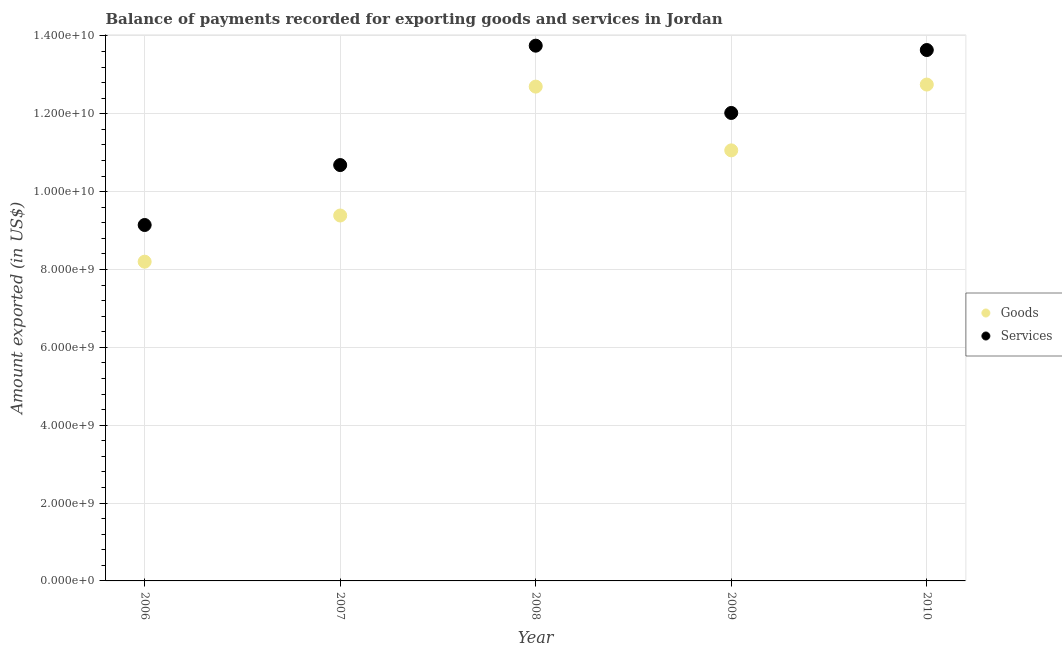How many different coloured dotlines are there?
Your answer should be compact. 2. Is the number of dotlines equal to the number of legend labels?
Offer a terse response. Yes. What is the amount of services exported in 2006?
Give a very brief answer. 9.14e+09. Across all years, what is the maximum amount of services exported?
Your answer should be compact. 1.38e+1. Across all years, what is the minimum amount of goods exported?
Your answer should be very brief. 8.20e+09. In which year was the amount of goods exported maximum?
Ensure brevity in your answer.  2010. In which year was the amount of goods exported minimum?
Your answer should be very brief. 2006. What is the total amount of goods exported in the graph?
Give a very brief answer. 5.41e+1. What is the difference between the amount of services exported in 2007 and that in 2008?
Your response must be concise. -3.07e+09. What is the difference between the amount of goods exported in 2007 and the amount of services exported in 2006?
Keep it short and to the point. 2.44e+08. What is the average amount of goods exported per year?
Your answer should be compact. 1.08e+1. In the year 2010, what is the difference between the amount of services exported and amount of goods exported?
Give a very brief answer. 8.87e+08. In how many years, is the amount of goods exported greater than 800000000 US$?
Your answer should be compact. 5. What is the ratio of the amount of goods exported in 2007 to that in 2009?
Ensure brevity in your answer.  0.85. Is the difference between the amount of services exported in 2008 and 2010 greater than the difference between the amount of goods exported in 2008 and 2010?
Give a very brief answer. Yes. What is the difference between the highest and the second highest amount of services exported?
Ensure brevity in your answer.  1.12e+08. What is the difference between the highest and the lowest amount of services exported?
Offer a terse response. 4.61e+09. In how many years, is the amount of services exported greater than the average amount of services exported taken over all years?
Make the answer very short. 3. Is the sum of the amount of services exported in 2006 and 2008 greater than the maximum amount of goods exported across all years?
Ensure brevity in your answer.  Yes. Does the amount of goods exported monotonically increase over the years?
Ensure brevity in your answer.  No. Is the amount of goods exported strictly greater than the amount of services exported over the years?
Your response must be concise. No. How many years are there in the graph?
Your answer should be very brief. 5. Are the values on the major ticks of Y-axis written in scientific E-notation?
Your answer should be very brief. Yes. Does the graph contain grids?
Make the answer very short. Yes. Where does the legend appear in the graph?
Your response must be concise. Center right. How are the legend labels stacked?
Keep it short and to the point. Vertical. What is the title of the graph?
Offer a terse response. Balance of payments recorded for exporting goods and services in Jordan. What is the label or title of the X-axis?
Give a very brief answer. Year. What is the label or title of the Y-axis?
Offer a very short reply. Amount exported (in US$). What is the Amount exported (in US$) in Goods in 2006?
Provide a succinct answer. 8.20e+09. What is the Amount exported (in US$) in Services in 2006?
Keep it short and to the point. 9.14e+09. What is the Amount exported (in US$) of Goods in 2007?
Give a very brief answer. 9.39e+09. What is the Amount exported (in US$) of Services in 2007?
Give a very brief answer. 1.07e+1. What is the Amount exported (in US$) of Goods in 2008?
Offer a terse response. 1.27e+1. What is the Amount exported (in US$) in Services in 2008?
Keep it short and to the point. 1.38e+1. What is the Amount exported (in US$) of Goods in 2009?
Your answer should be compact. 1.11e+1. What is the Amount exported (in US$) of Services in 2009?
Your response must be concise. 1.20e+1. What is the Amount exported (in US$) in Goods in 2010?
Your answer should be very brief. 1.28e+1. What is the Amount exported (in US$) in Services in 2010?
Keep it short and to the point. 1.36e+1. Across all years, what is the maximum Amount exported (in US$) of Goods?
Keep it short and to the point. 1.28e+1. Across all years, what is the maximum Amount exported (in US$) of Services?
Make the answer very short. 1.38e+1. Across all years, what is the minimum Amount exported (in US$) in Goods?
Offer a very short reply. 8.20e+09. Across all years, what is the minimum Amount exported (in US$) in Services?
Ensure brevity in your answer.  9.14e+09. What is the total Amount exported (in US$) of Goods in the graph?
Keep it short and to the point. 5.41e+1. What is the total Amount exported (in US$) of Services in the graph?
Offer a terse response. 5.92e+1. What is the difference between the Amount exported (in US$) of Goods in 2006 and that in 2007?
Keep it short and to the point. -1.19e+09. What is the difference between the Amount exported (in US$) in Services in 2006 and that in 2007?
Offer a very short reply. -1.54e+09. What is the difference between the Amount exported (in US$) of Goods in 2006 and that in 2008?
Your answer should be very brief. -4.50e+09. What is the difference between the Amount exported (in US$) in Services in 2006 and that in 2008?
Offer a terse response. -4.61e+09. What is the difference between the Amount exported (in US$) of Goods in 2006 and that in 2009?
Provide a short and direct response. -2.86e+09. What is the difference between the Amount exported (in US$) of Services in 2006 and that in 2009?
Provide a short and direct response. -2.88e+09. What is the difference between the Amount exported (in US$) in Goods in 2006 and that in 2010?
Provide a short and direct response. -4.55e+09. What is the difference between the Amount exported (in US$) of Services in 2006 and that in 2010?
Your response must be concise. -4.50e+09. What is the difference between the Amount exported (in US$) in Goods in 2007 and that in 2008?
Your response must be concise. -3.31e+09. What is the difference between the Amount exported (in US$) of Services in 2007 and that in 2008?
Make the answer very short. -3.07e+09. What is the difference between the Amount exported (in US$) of Goods in 2007 and that in 2009?
Provide a short and direct response. -1.67e+09. What is the difference between the Amount exported (in US$) of Services in 2007 and that in 2009?
Give a very brief answer. -1.34e+09. What is the difference between the Amount exported (in US$) of Goods in 2007 and that in 2010?
Your response must be concise. -3.36e+09. What is the difference between the Amount exported (in US$) of Services in 2007 and that in 2010?
Ensure brevity in your answer.  -2.96e+09. What is the difference between the Amount exported (in US$) of Goods in 2008 and that in 2009?
Give a very brief answer. 1.64e+09. What is the difference between the Amount exported (in US$) of Services in 2008 and that in 2009?
Make the answer very short. 1.73e+09. What is the difference between the Amount exported (in US$) of Goods in 2008 and that in 2010?
Your answer should be compact. -5.28e+07. What is the difference between the Amount exported (in US$) in Services in 2008 and that in 2010?
Offer a very short reply. 1.12e+08. What is the difference between the Amount exported (in US$) in Goods in 2009 and that in 2010?
Offer a terse response. -1.69e+09. What is the difference between the Amount exported (in US$) in Services in 2009 and that in 2010?
Provide a succinct answer. -1.62e+09. What is the difference between the Amount exported (in US$) of Goods in 2006 and the Amount exported (in US$) of Services in 2007?
Your response must be concise. -2.48e+09. What is the difference between the Amount exported (in US$) of Goods in 2006 and the Amount exported (in US$) of Services in 2008?
Offer a terse response. -5.55e+09. What is the difference between the Amount exported (in US$) of Goods in 2006 and the Amount exported (in US$) of Services in 2009?
Your answer should be compact. -3.82e+09. What is the difference between the Amount exported (in US$) in Goods in 2006 and the Amount exported (in US$) in Services in 2010?
Give a very brief answer. -5.44e+09. What is the difference between the Amount exported (in US$) in Goods in 2007 and the Amount exported (in US$) in Services in 2008?
Ensure brevity in your answer.  -4.36e+09. What is the difference between the Amount exported (in US$) in Goods in 2007 and the Amount exported (in US$) in Services in 2009?
Your answer should be very brief. -2.63e+09. What is the difference between the Amount exported (in US$) in Goods in 2007 and the Amount exported (in US$) in Services in 2010?
Your response must be concise. -4.25e+09. What is the difference between the Amount exported (in US$) in Goods in 2008 and the Amount exported (in US$) in Services in 2009?
Provide a succinct answer. 6.77e+08. What is the difference between the Amount exported (in US$) in Goods in 2008 and the Amount exported (in US$) in Services in 2010?
Your response must be concise. -9.40e+08. What is the difference between the Amount exported (in US$) in Goods in 2009 and the Amount exported (in US$) in Services in 2010?
Provide a short and direct response. -2.58e+09. What is the average Amount exported (in US$) in Goods per year?
Your answer should be very brief. 1.08e+1. What is the average Amount exported (in US$) of Services per year?
Ensure brevity in your answer.  1.18e+1. In the year 2006, what is the difference between the Amount exported (in US$) of Goods and Amount exported (in US$) of Services?
Offer a terse response. -9.43e+08. In the year 2007, what is the difference between the Amount exported (in US$) in Goods and Amount exported (in US$) in Services?
Keep it short and to the point. -1.30e+09. In the year 2008, what is the difference between the Amount exported (in US$) in Goods and Amount exported (in US$) in Services?
Your answer should be compact. -1.05e+09. In the year 2009, what is the difference between the Amount exported (in US$) in Goods and Amount exported (in US$) in Services?
Your response must be concise. -9.61e+08. In the year 2010, what is the difference between the Amount exported (in US$) of Goods and Amount exported (in US$) of Services?
Give a very brief answer. -8.87e+08. What is the ratio of the Amount exported (in US$) in Goods in 2006 to that in 2007?
Give a very brief answer. 0.87. What is the ratio of the Amount exported (in US$) of Services in 2006 to that in 2007?
Keep it short and to the point. 0.86. What is the ratio of the Amount exported (in US$) in Goods in 2006 to that in 2008?
Offer a very short reply. 0.65. What is the ratio of the Amount exported (in US$) in Services in 2006 to that in 2008?
Your response must be concise. 0.67. What is the ratio of the Amount exported (in US$) in Goods in 2006 to that in 2009?
Provide a succinct answer. 0.74. What is the ratio of the Amount exported (in US$) of Services in 2006 to that in 2009?
Your answer should be very brief. 0.76. What is the ratio of the Amount exported (in US$) of Goods in 2006 to that in 2010?
Provide a short and direct response. 0.64. What is the ratio of the Amount exported (in US$) of Services in 2006 to that in 2010?
Provide a succinct answer. 0.67. What is the ratio of the Amount exported (in US$) in Goods in 2007 to that in 2008?
Ensure brevity in your answer.  0.74. What is the ratio of the Amount exported (in US$) of Services in 2007 to that in 2008?
Provide a short and direct response. 0.78. What is the ratio of the Amount exported (in US$) in Goods in 2007 to that in 2009?
Provide a short and direct response. 0.85. What is the ratio of the Amount exported (in US$) of Services in 2007 to that in 2009?
Make the answer very short. 0.89. What is the ratio of the Amount exported (in US$) in Goods in 2007 to that in 2010?
Give a very brief answer. 0.74. What is the ratio of the Amount exported (in US$) in Services in 2007 to that in 2010?
Provide a succinct answer. 0.78. What is the ratio of the Amount exported (in US$) in Goods in 2008 to that in 2009?
Your answer should be very brief. 1.15. What is the ratio of the Amount exported (in US$) of Services in 2008 to that in 2009?
Your answer should be compact. 1.14. What is the ratio of the Amount exported (in US$) of Goods in 2008 to that in 2010?
Provide a succinct answer. 1. What is the ratio of the Amount exported (in US$) in Services in 2008 to that in 2010?
Give a very brief answer. 1.01. What is the ratio of the Amount exported (in US$) of Goods in 2009 to that in 2010?
Offer a terse response. 0.87. What is the ratio of the Amount exported (in US$) in Services in 2009 to that in 2010?
Your answer should be very brief. 0.88. What is the difference between the highest and the second highest Amount exported (in US$) of Goods?
Provide a succinct answer. 5.28e+07. What is the difference between the highest and the second highest Amount exported (in US$) of Services?
Offer a very short reply. 1.12e+08. What is the difference between the highest and the lowest Amount exported (in US$) of Goods?
Ensure brevity in your answer.  4.55e+09. What is the difference between the highest and the lowest Amount exported (in US$) in Services?
Provide a short and direct response. 4.61e+09. 